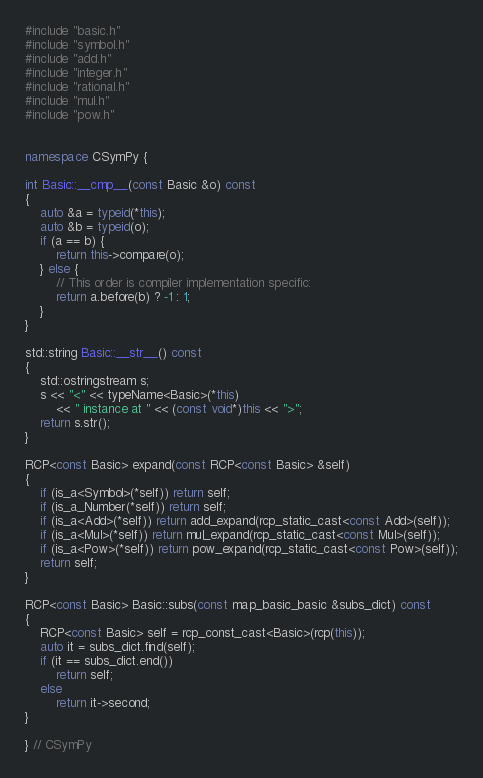<code> <loc_0><loc_0><loc_500><loc_500><_C++_>#include "basic.h"
#include "symbol.h"
#include "add.h"
#include "integer.h"
#include "rational.h"
#include "mul.h"
#include "pow.h"


namespace CSymPy {

int Basic::__cmp__(const Basic &o) const
{
    auto &a = typeid(*this);
    auto &b = typeid(o);
    if (a == b) {
        return this->compare(o);
    } else {
        // This order is compiler implementation specific:
        return a.before(b) ? -1 : 1;
    }
}

std::string Basic::__str__() const
{
    std::ostringstream s;
    s << "<" << typeName<Basic>(*this)
        << " instance at " << (const void*)this << ">";
    return s.str();
}

RCP<const Basic> expand(const RCP<const Basic> &self)
{
    if (is_a<Symbol>(*self)) return self;
    if (is_a_Number(*self)) return self;
    if (is_a<Add>(*self)) return add_expand(rcp_static_cast<const Add>(self));
    if (is_a<Mul>(*self)) return mul_expand(rcp_static_cast<const Mul>(self));
    if (is_a<Pow>(*self)) return pow_expand(rcp_static_cast<const Pow>(self));
    return self;
}

RCP<const Basic> Basic::subs(const map_basic_basic &subs_dict) const
{
    RCP<const Basic> self = rcp_const_cast<Basic>(rcp(this));
    auto it = subs_dict.find(self);
    if (it == subs_dict.end())
        return self;
    else
        return it->second;
}

} // CSymPy

</code> 